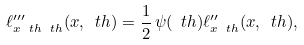Convert formula to latex. <formula><loc_0><loc_0><loc_500><loc_500>\ell ^ { \prime \prime \prime } _ { x \ t h \ t h } ( x , \ t h ) = \frac { 1 } { 2 } \, \psi ( \ t h ) \ell ^ { \prime \prime } _ { x \ t h } ( x , \ t h ) ,</formula> 